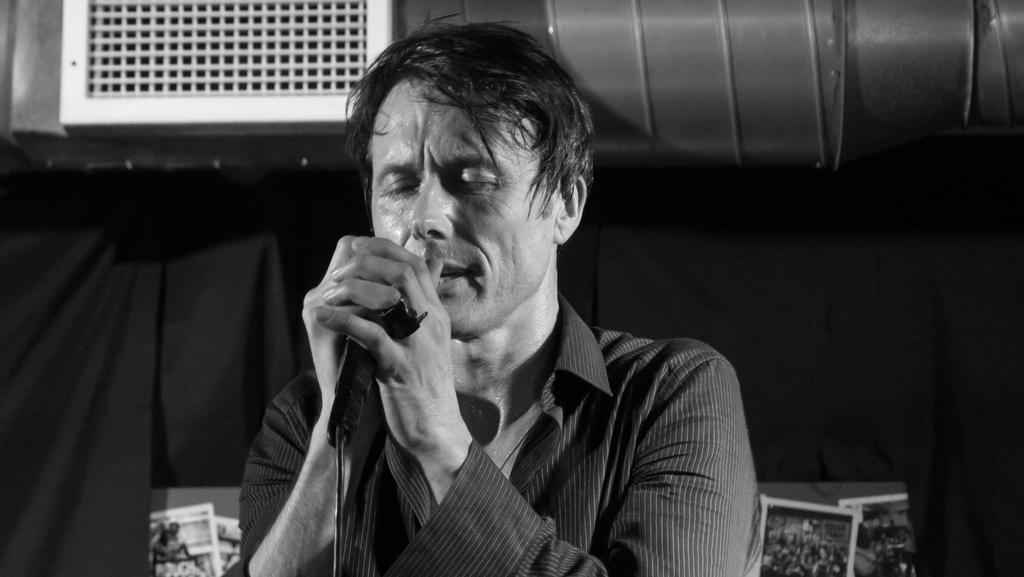What is the main subject of the image? There is a man in the middle of the image. What is the man holding in the image? The man is holding a microphone. Can you describe any background elements in the image? There is an air conditioner pipe visible behind the man. What is the color scheme of the image? The image is in black and white. How many pizzas are being exchanged between the man and the audience in the image? There are no pizzas present in the image, and no exchange is taking place. What type of sorting algorithm is the man using to organize the data on the microphone? The image does not depict any sorting algorithm or data organization; the man is simply holding a microphone. 